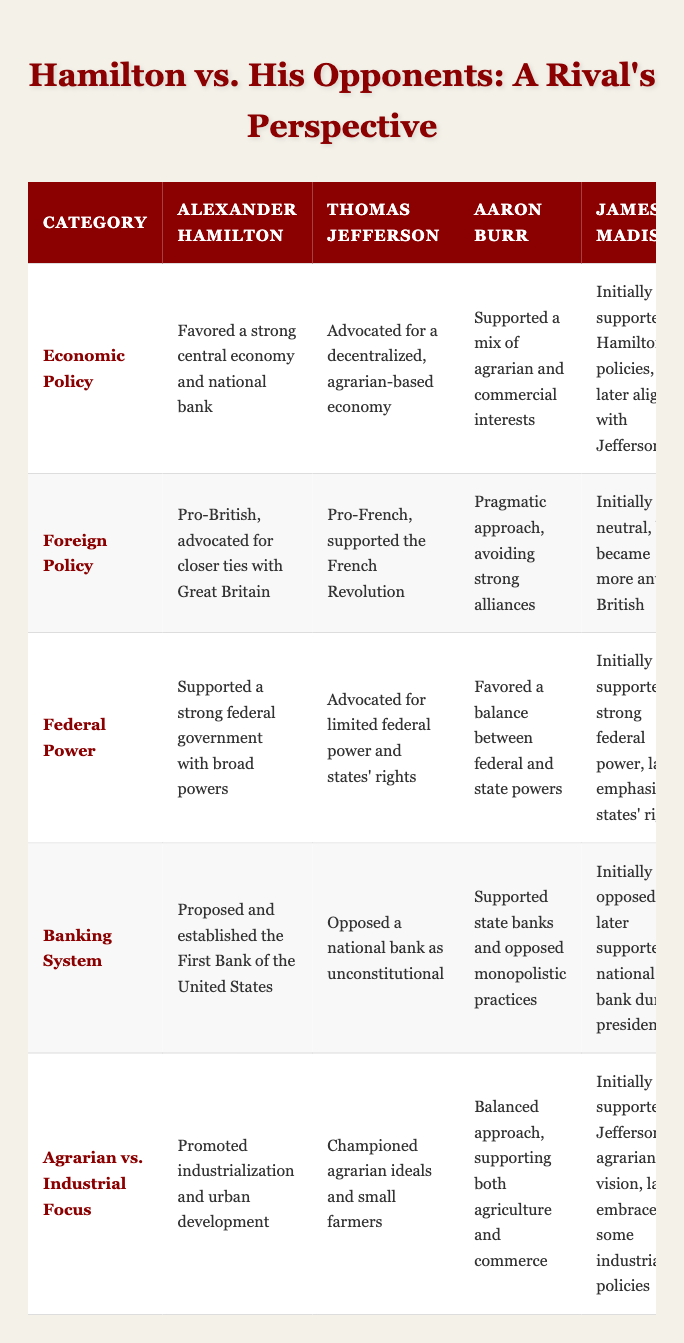What was Hamilton's stance on economic policy? Hamilton favored a strong central economy and the establishment of a national bank, emphasizing the importance of a robust financial system for national growth.
Answer: Hamilton favored a strong central economy and national bank How did Jefferson's view on the banking system differ from Hamilton's? Jefferson opposed a national bank as unconstitutional, while Hamilton proposed and established the First Bank of the United States. Their views starkly contrasted on this financial institution.
Answer: Jefferson opposed a national bank True or False: All four politicians supported a strong federal government. The table shows that Hamilton supported a strong federal government, while Jefferson advocated for limited federal power. Therefore, the statement is false.
Answer: False What commonality is found between Burr and Madison regarding federal power? Both Burr and Madison favored a balanced approach to federal and state power, neither fully endorsing the extreme of strong federal authority nor complete states' rights. They shared a similar perspective in seeking a middle ground.
Answer: They both favored a balance between federal and state powers Which politician championed agrarian ideals and small farmers? Jefferson advocated for agrarian ideals and the interests of small farmers, standing in contrast to Hamilton's industrial focus. This represents a significant divide in their economic philosophies.
Answer: Jefferson championed agrarian ideals and small farmers How many politicians supported the establishment of a national bank? Only Hamilton and Madison (later in his presidency) supported the national bank, while Jefferson was against it, and Burr primarily focused on state banks. Thus, the total comes to two politicians.
Answer: Two politicians supported it What was Hamilton's foreign policy orientation compared to Jefferson's? Hamilton was pro-British, advocating closer ties with Great Britain, while Jefferson was pro-French and supported the French Revolution, highlighting a significant divide in their foreign policy ideologies.
Answer: Hamilton was pro-British; Jefferson was pro-French Who had a pragmatic approach to foreign alliances, and how did it differ from Hamilton’s view? Burr had a pragmatic approach avoiding strong alliances, which is in stark contrast to Hamilton’s pro-British sentiment, indicating that Burr preferred to remain neutral or flexible rather than favor a specific nation.
Answer: Burr had a pragmatic approach, differing from Hamilton's pro-British view 